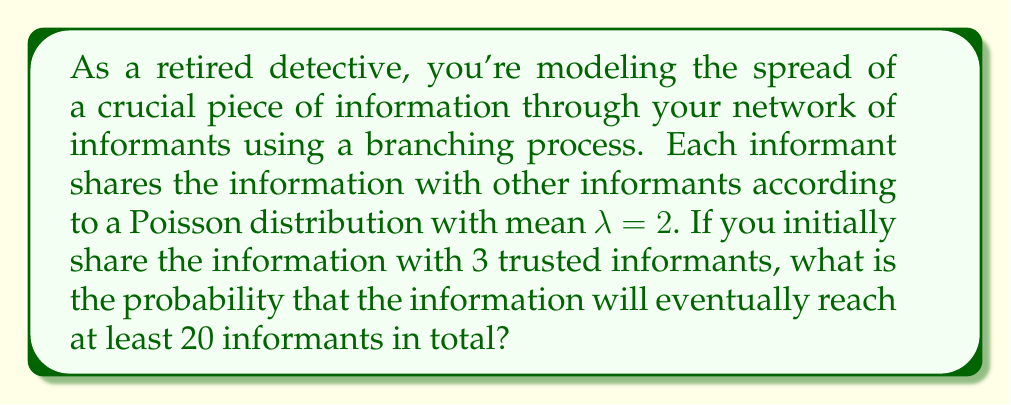Can you solve this math problem? To solve this problem, we'll use the theory of branching processes:

1) First, we need to calculate the extinction probability $q$ of the process. In a Poisson branching process, $q$ satisfies the equation:

   $q = e^{-\lambda(1-q)}$

2) We can solve this numerically. With $\lambda = 2$, we get:

   $q \approx 0.2032$

3) The probability of the process not going extinct when starting with one individual is $1-q$. 

4) Since we start with 3 independent informants, the probability of at least one of these processes not going extinct is:

   $1 - q^3 = 1 - (0.2032)^3 \approx 0.9917$

5) If the process doesn't go extinct, it will eventually reach any finite number of informants with probability 1.

6) Therefore, the probability of reaching at least 20 informants is the same as the probability of not going extinct, which is approximately 0.9917.
Answer: $0.9917$ 